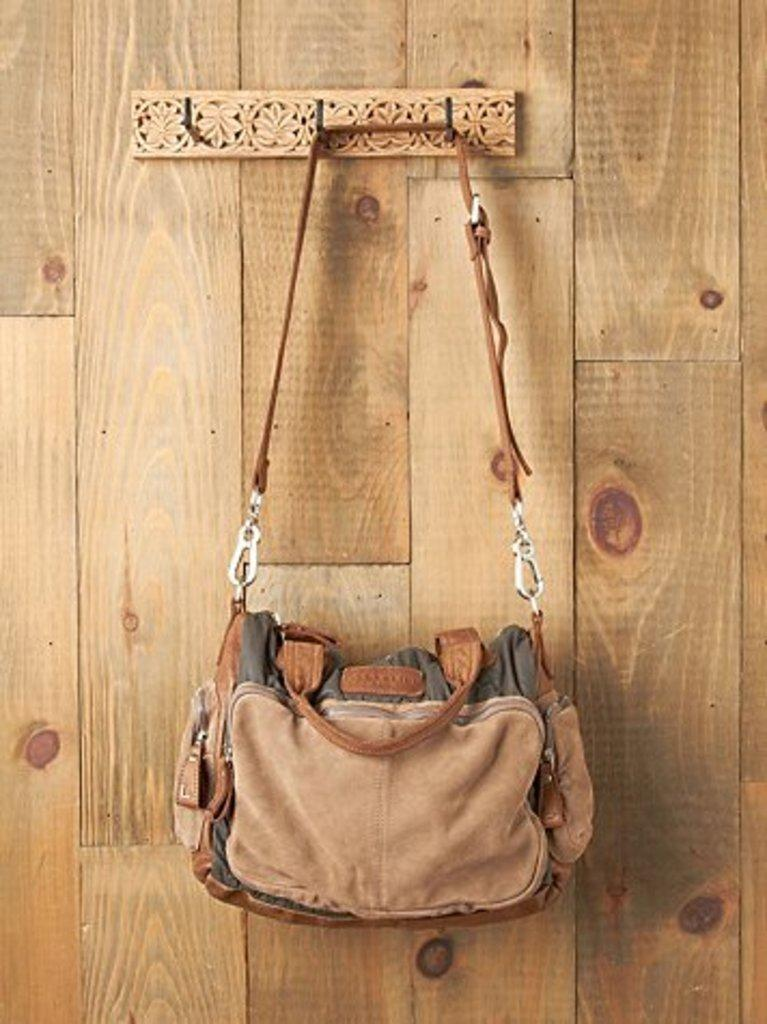What object is present in the image? There is a bag in the image. How is the bag positioned in the image? The bag is hanging on a hanger. Where is the hanger located in the image? The hanger is attached to a wall. What rhythm is the fireman playing on the edge of the wall in the image? There is no fireman or rhythm present in the image; it only features a bag hanging on a hanger attached to a wall. 